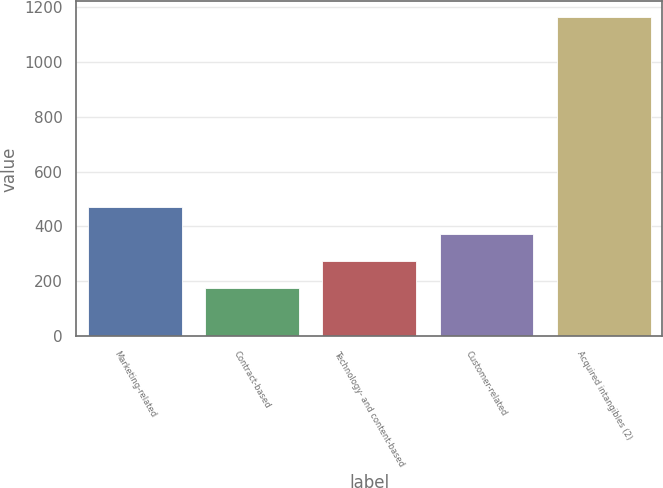Convert chart to OTSL. <chart><loc_0><loc_0><loc_500><loc_500><bar_chart><fcel>Marketing-related<fcel>Contract-based<fcel>Technology- and content-based<fcel>Customer-related<fcel>Acquired intangibles (2)<nl><fcel>472.5<fcel>177<fcel>275.5<fcel>374<fcel>1162<nl></chart> 